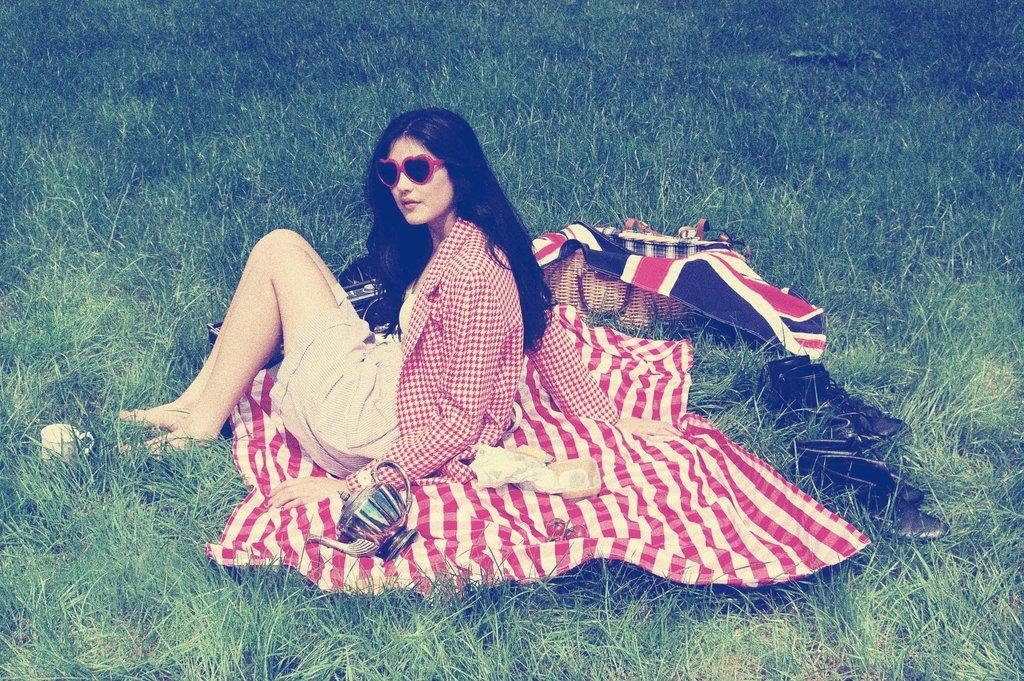What is the main subject of the image? There is a person in the image. What is the person wearing? The person is wearing a red shirt. What is the person sitting on? The person is sitting on a red cloth. What items can be seen on the cloth? There are shoe pairs, baskets, boxes, a coffee cup, and a tea kettle on the cloth. What type of orange can be seen in the image? There is no orange present in the image. Is there a zebra visible in the image? No, there is no zebra in the image. 